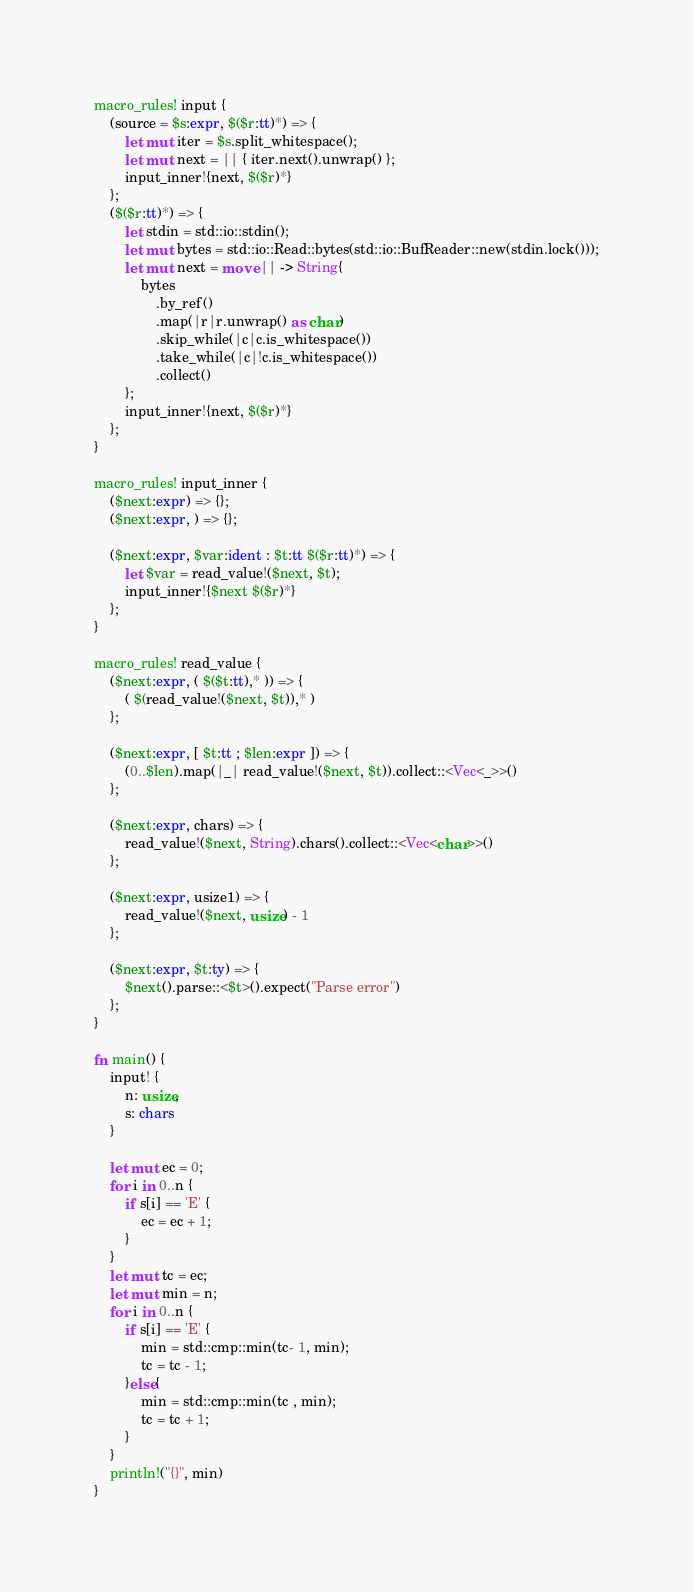Convert code to text. <code><loc_0><loc_0><loc_500><loc_500><_Rust_>macro_rules! input {
    (source = $s:expr, $($r:tt)*) => {
        let mut iter = $s.split_whitespace();
        let mut next = || { iter.next().unwrap() };
        input_inner!{next, $($r)*}
    };
    ($($r:tt)*) => {
        let stdin = std::io::stdin();
        let mut bytes = std::io::Read::bytes(std::io::BufReader::new(stdin.lock()));
        let mut next = move || -> String{
            bytes
                .by_ref()
                .map(|r|r.unwrap() as char)
                .skip_while(|c|c.is_whitespace())
                .take_while(|c|!c.is_whitespace())
                .collect()
        };
        input_inner!{next, $($r)*}
    };
}

macro_rules! input_inner {
    ($next:expr) => {};
    ($next:expr, ) => {};

    ($next:expr, $var:ident : $t:tt $($r:tt)*) => {
        let $var = read_value!($next, $t);
        input_inner!{$next $($r)*}
    };
}

macro_rules! read_value {
    ($next:expr, ( $($t:tt),* )) => {
        ( $(read_value!($next, $t)),* )
    };

    ($next:expr, [ $t:tt ; $len:expr ]) => {
        (0..$len).map(|_| read_value!($next, $t)).collect::<Vec<_>>()
    };

    ($next:expr, chars) => {
        read_value!($next, String).chars().collect::<Vec<char>>()
    };

    ($next:expr, usize1) => {
        read_value!($next, usize) - 1
    };

    ($next:expr, $t:ty) => {
        $next().parse::<$t>().expect("Parse error")
    };
}

fn main() {
    input! {
        n: usize,
        s: chars
    }

    let mut ec = 0;
    for i in 0..n {
        if s[i] == 'E' {
            ec = ec + 1;
        }
    }
    let mut tc = ec;
    let mut min = n;
    for i in 0..n {
        if s[i] == 'E' {
            min = std::cmp::min(tc- 1, min);
            tc = tc - 1;
        }else{
            min = std::cmp::min(tc , min);
            tc = tc + 1;
        }
    }
    println!("{}", min)
}
</code> 